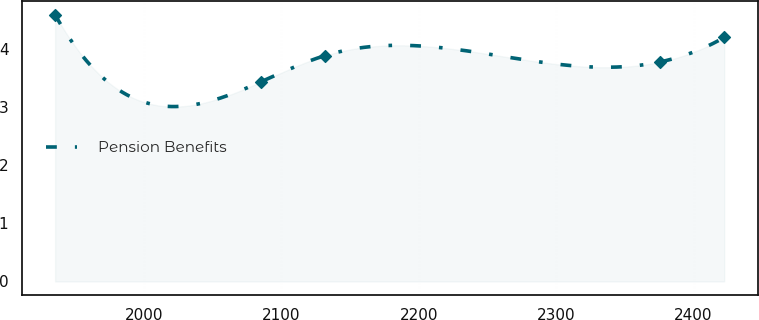<chart> <loc_0><loc_0><loc_500><loc_500><line_chart><ecel><fcel>Pension Benefits<nl><fcel>1935.16<fcel>4.58<nl><fcel>2085.16<fcel>3.43<nl><fcel>2131.89<fcel>3.88<nl><fcel>2375.55<fcel>3.77<nl><fcel>2422.28<fcel>4.19<nl></chart> 